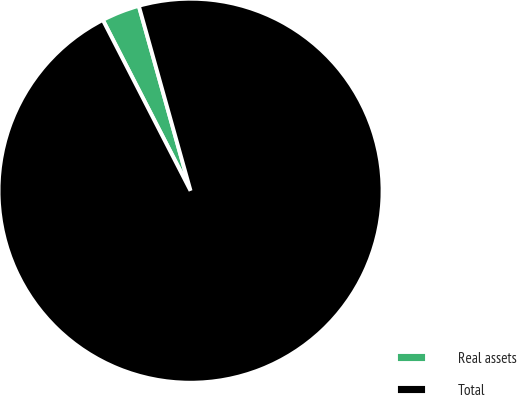Convert chart. <chart><loc_0><loc_0><loc_500><loc_500><pie_chart><fcel>Real assets<fcel>Total<nl><fcel>3.21%<fcel>96.79%<nl></chart> 